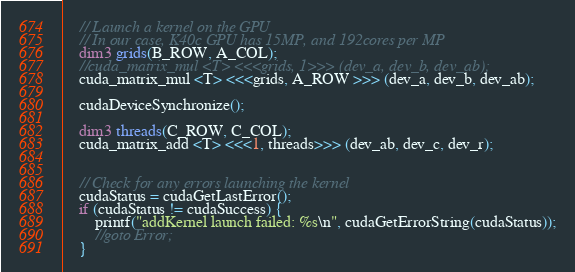<code> <loc_0><loc_0><loc_500><loc_500><_Cuda_>
	// Launch a kernel on the GPU
	// In our case, K40c GPU has 15MP, and 192cores per MP
	dim3 grids(B_ROW, A_COL);
	//cuda_matrix_mul <T> <<<grids, 1>>> (dev_a, dev_b, dev_ab);
	cuda_matrix_mul <T> <<<grids, A_ROW >>> (dev_a, dev_b, dev_ab);

	cudaDeviceSynchronize();

	dim3 threads(C_ROW, C_COL);
	cuda_matrix_add <T> <<<1, threads>>> (dev_ab, dev_c, dev_r);


	// Check for any errors launching the kernel
	cudaStatus = cudaGetLastError();
	if (cudaStatus != cudaSuccess) {
		printf("addKernel launch failed: %s\n", cudaGetErrorString(cudaStatus));
		//goto Error;
	}
</code> 